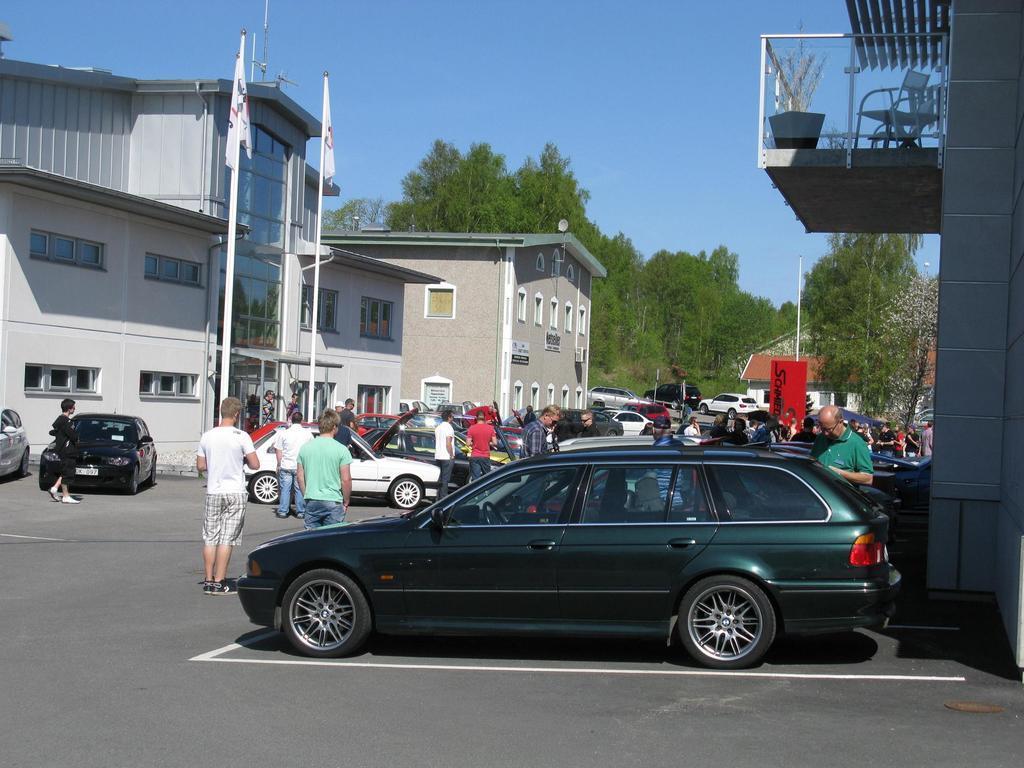Please provide a concise description of this image. In this image we can see a group of cars and people standing on the surface. On the left and right corner of the image they are a few buildings and in the middle of the image we can see two flags with pole. Behind the building there are some group of trees over a clear sky. 